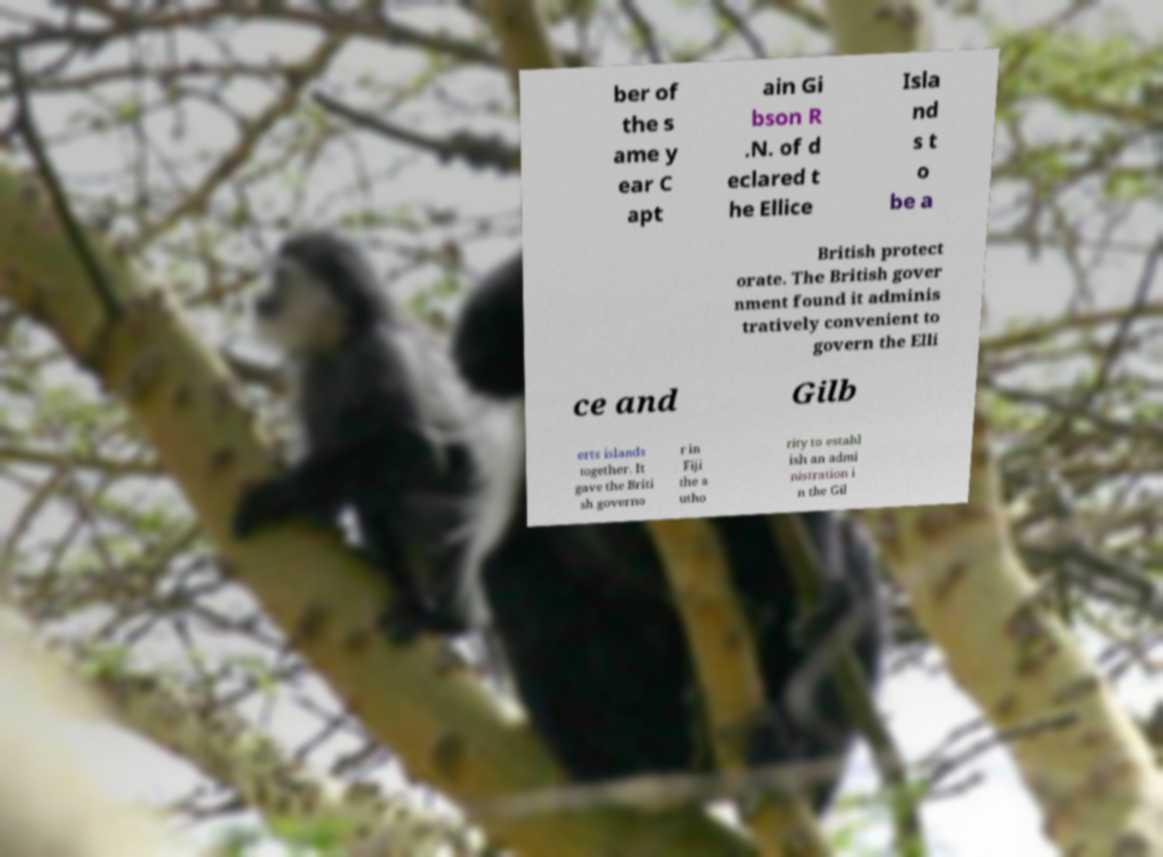There's text embedded in this image that I need extracted. Can you transcribe it verbatim? ber of the s ame y ear C apt ain Gi bson R .N. of d eclared t he Ellice Isla nd s t o be a British protect orate. The British gover nment found it adminis tratively convenient to govern the Elli ce and Gilb erts islands together. It gave the Briti sh governo r in Fiji the a utho rity to establ ish an admi nistration i n the Gil 